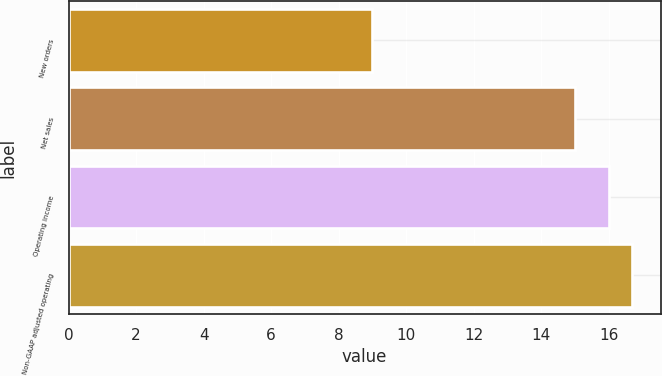Convert chart. <chart><loc_0><loc_0><loc_500><loc_500><bar_chart><fcel>New orders<fcel>Net sales<fcel>Operating income<fcel>Non-GAAP adjusted operating<nl><fcel>9<fcel>15<fcel>16<fcel>16.7<nl></chart> 